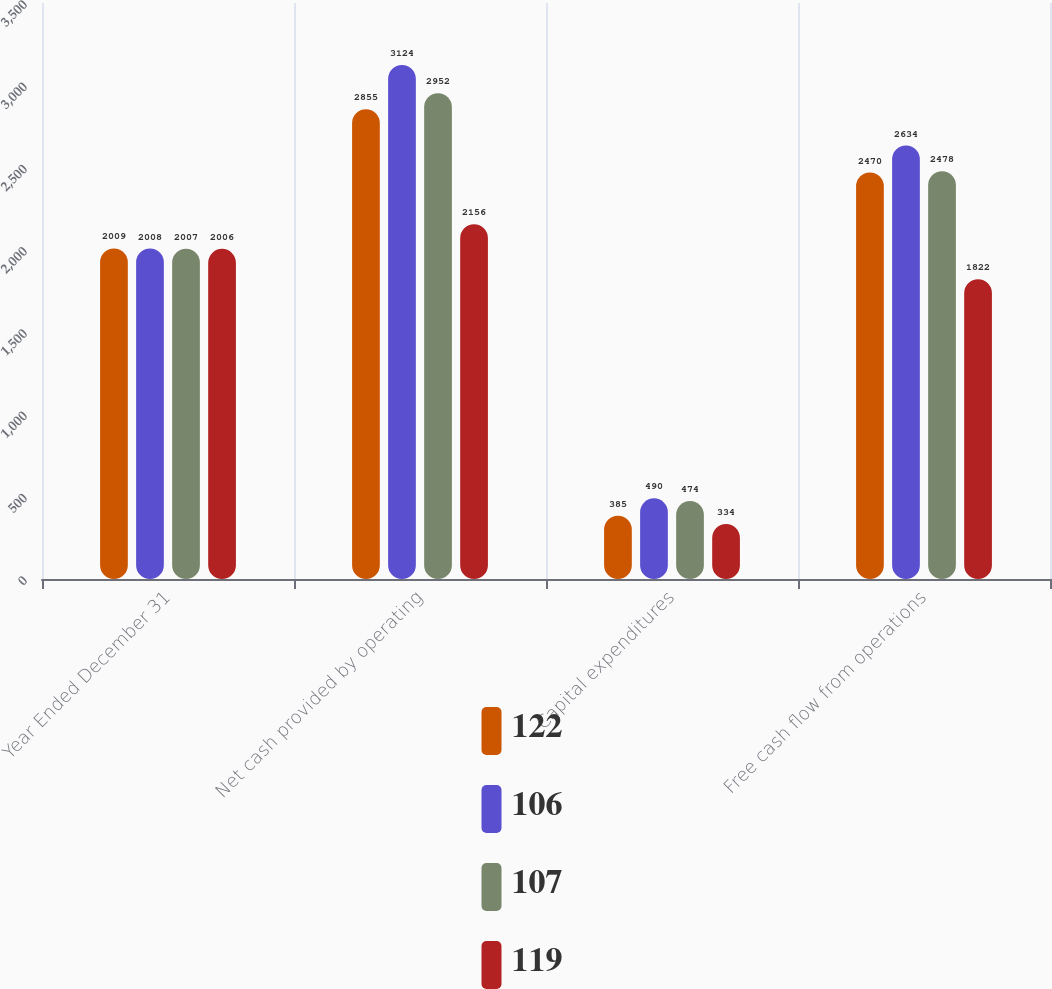<chart> <loc_0><loc_0><loc_500><loc_500><stacked_bar_chart><ecel><fcel>Year Ended December 31<fcel>Net cash provided by operating<fcel>Capital expenditures<fcel>Free cash flow from operations<nl><fcel>122<fcel>2009<fcel>2855<fcel>385<fcel>2470<nl><fcel>106<fcel>2008<fcel>3124<fcel>490<fcel>2634<nl><fcel>107<fcel>2007<fcel>2952<fcel>474<fcel>2478<nl><fcel>119<fcel>2006<fcel>2156<fcel>334<fcel>1822<nl></chart> 